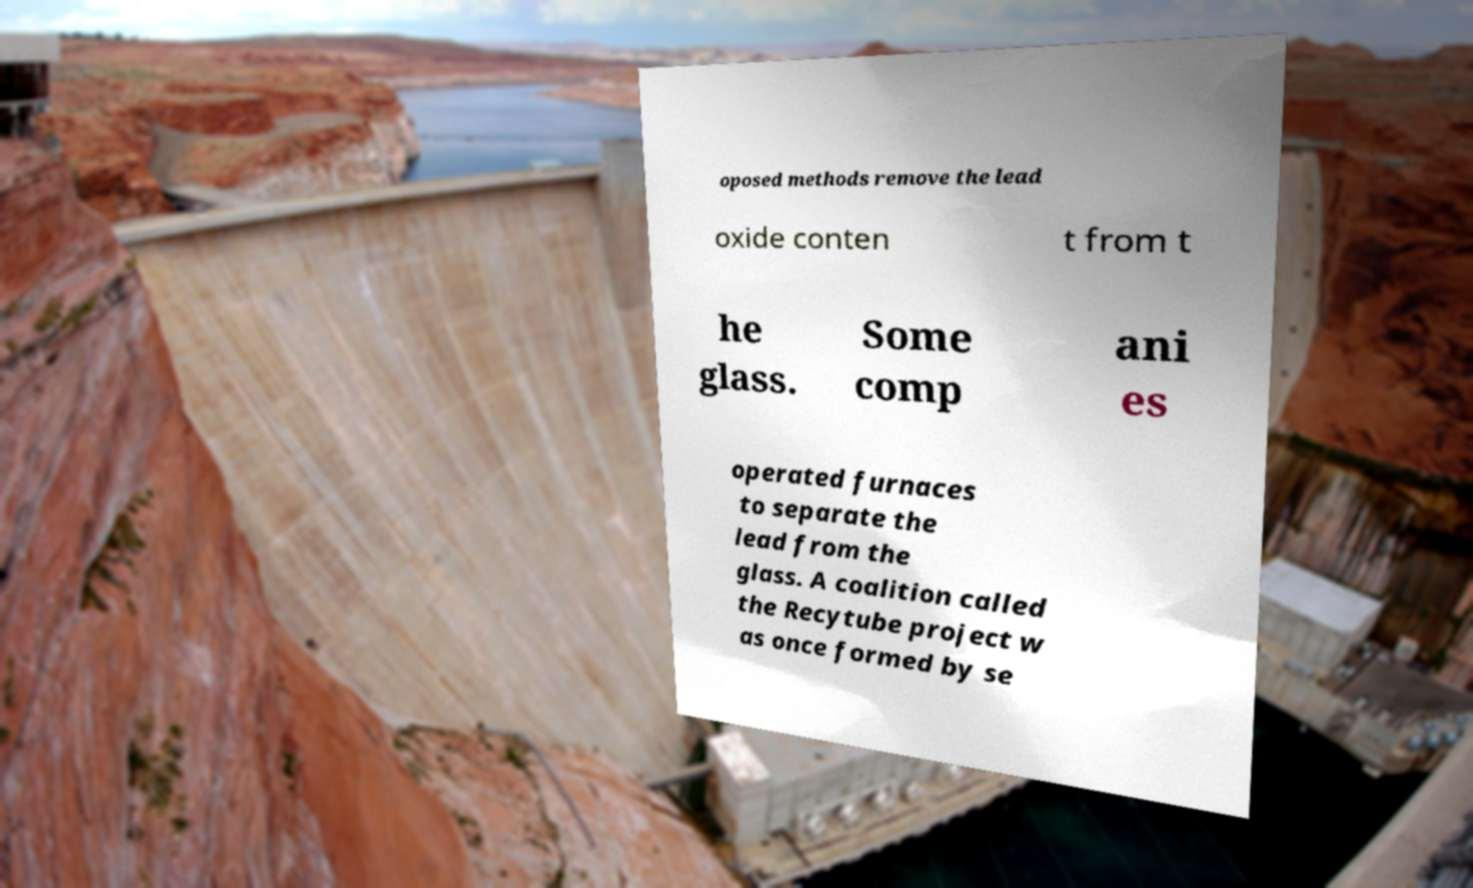Please read and relay the text visible in this image. What does it say? oposed methods remove the lead oxide conten t from t he glass. Some comp ani es operated furnaces to separate the lead from the glass. A coalition called the Recytube project w as once formed by se 